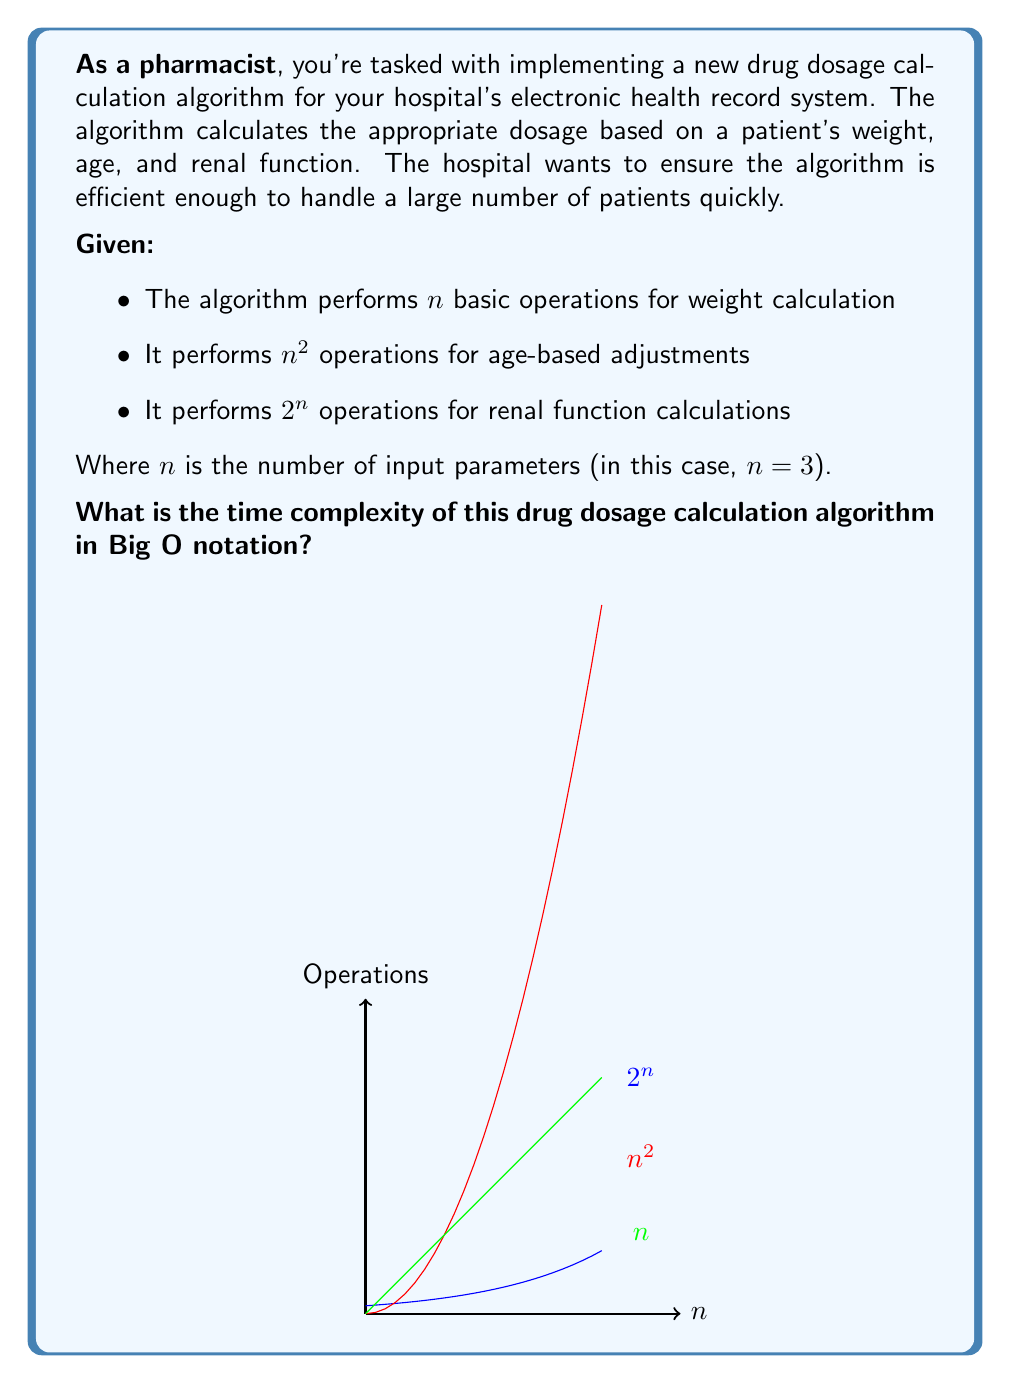Help me with this question. To determine the time complexity of the algorithm, we need to analyze the number of operations performed for each part of the calculation and identify the dominant term. Let's break it down step-by-step:

1) Weight calculation: $n$ operations
   With $n = 3$, this is $O(3) = O(1)$ (constant time)

2) Age-based adjustments: $n^2$ operations
   With $n = 3$, this is $O(3^2) = O(9) = O(1)$ (constant time)

3) Renal function calculations: $2^n$ operations
   With $n = 3$, this is $O(2^3) = O(8) = O(1)$ (constant time)

4) Total number of operations: $n + n^2 + 2^n$
   With $n = 3$, this is $3 + 3^2 + 2^3 = 3 + 9 + 8 = 20$

5) In general, for any algorithm, we consider the worst-case scenario and the term with the highest growth rate as $n$ increases.

6) Among $n$, $n^2$, and $2^n$, the term $2^n$ grows the fastest as $n$ increases.

7) Therefore, the time complexity of this algorithm is dominated by the $2^n$ term.

In Big O notation, we express this as $O(2^n)$, which represents exponential time complexity.
Answer: $O(2^n)$ 